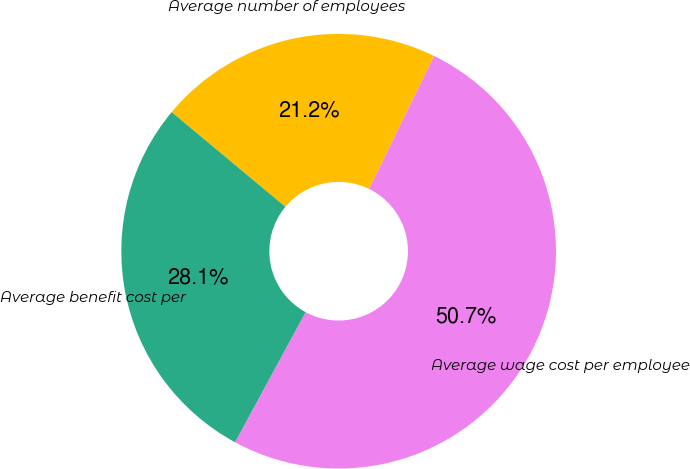<chart> <loc_0><loc_0><loc_500><loc_500><pie_chart><fcel>Average number of employees<fcel>Average wage cost per employee<fcel>Average benefit cost per<nl><fcel>21.18%<fcel>50.67%<fcel>28.15%<nl></chart> 